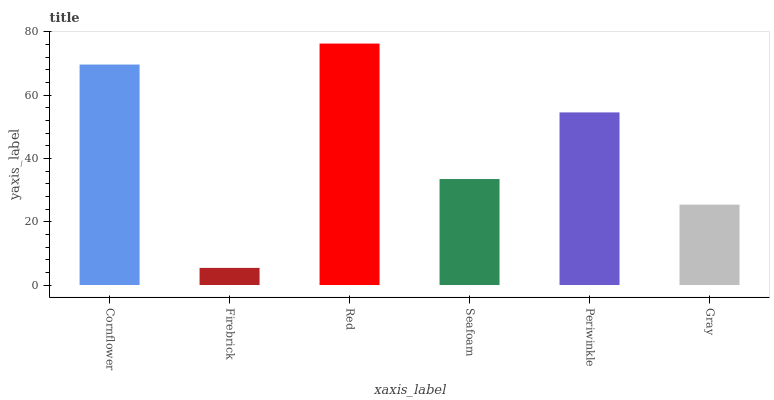Is Firebrick the minimum?
Answer yes or no. Yes. Is Red the maximum?
Answer yes or no. Yes. Is Red the minimum?
Answer yes or no. No. Is Firebrick the maximum?
Answer yes or no. No. Is Red greater than Firebrick?
Answer yes or no. Yes. Is Firebrick less than Red?
Answer yes or no. Yes. Is Firebrick greater than Red?
Answer yes or no. No. Is Red less than Firebrick?
Answer yes or no. No. Is Periwinkle the high median?
Answer yes or no. Yes. Is Seafoam the low median?
Answer yes or no. Yes. Is Cornflower the high median?
Answer yes or no. No. Is Gray the low median?
Answer yes or no. No. 